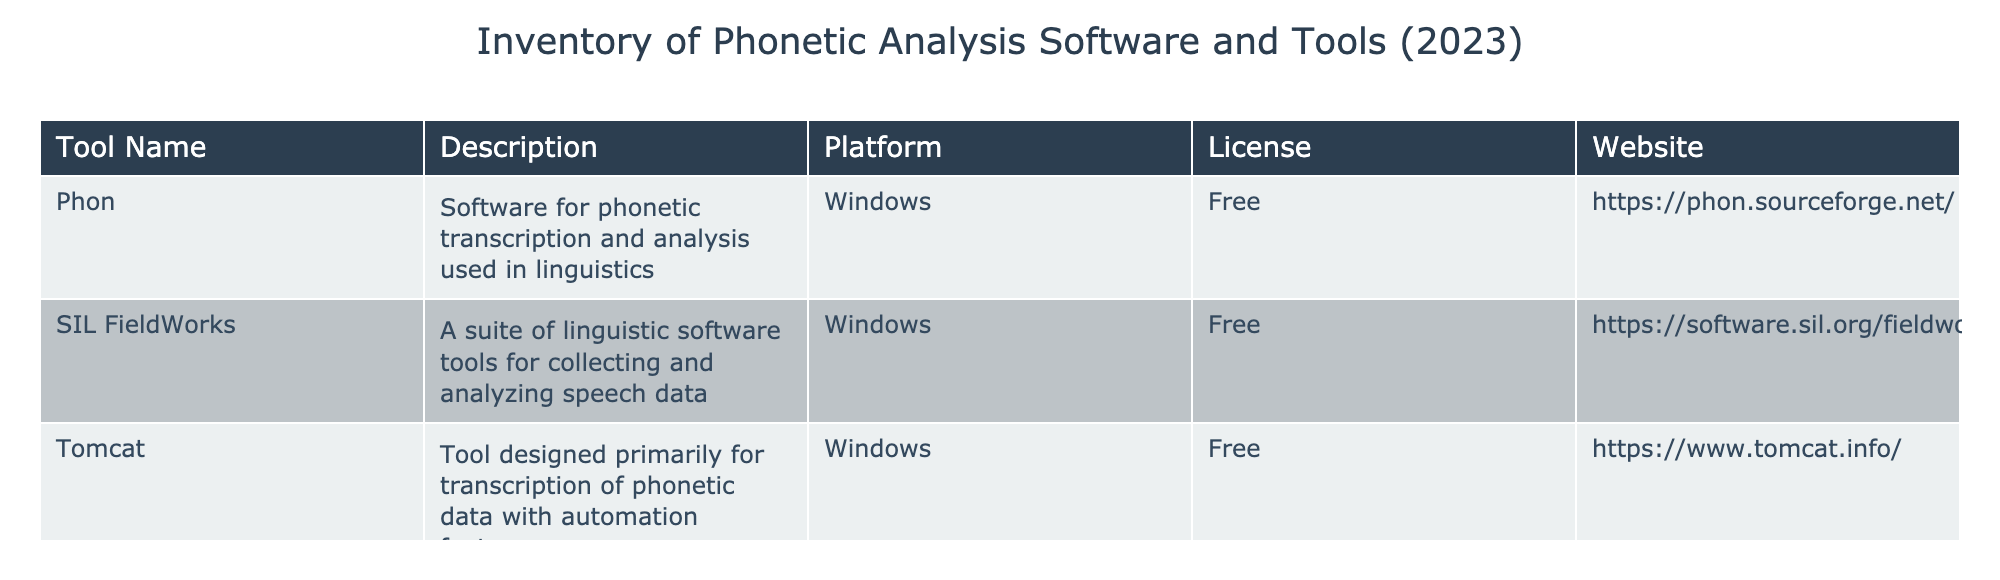What is the name of the software used for phonetic transcription and analysis in linguistics? The table lists "Phon" as the software specifically mentioned for phonetic transcription and analysis in linguistics under the "Description" column.
Answer: Phon Which tools are offered for the Windows platform? All tools listed in the table ("Phon", "SIL FieldWorks", and "Tomcat") are specified to be available on the Windows platform, as indicated in the "Platform" column.
Answer: Phon, SIL FieldWorks, Tomcat Is there any tool in the inventory that requires a paid license? By reviewing the "License" column in the table, all tools listed are marked as "Free", indicating no tool requires a paid license.
Answer: No How many tools in the inventory are available for free? The table contains three tools, all of which are labeled under the "License" column as "Free". Therefore, the total count of tools available for free is 3.
Answer: 3 What website can be visited to access the "SIL FieldWorks" tool? The table provides the website link for "SIL FieldWorks" as listed under the "Website" column. The corresponding link is "https://software.sil.org/fieldworks/".
Answer: https://software.sil.org/fieldworks/ Which tool has a description focusing on transcription and also includes automation features? "Tomcat" is noted in the table as a tool designed primarily for transcription of phonetic data with specific mention of automation features in the "Description" column.
Answer: Tomcat Which tool listed is specifically designated for collecting and analyzing speech data? The description of "SIL FieldWorks" clearly states that it is a suite of linguistic software tools for collecting and analyzing speech data, confirming its specific designation for this purpose.
Answer: SIL FieldWorks Is "Phon" the only tool mentioned that offers analysis features? The table lists "Phon" for phonetic transcription and analysis, but also "SIL FieldWorks" is represented as a software suite for collecting and analyzing speech data, indicating that Phon is not the only tool with analysis features.
Answer: No Which tools could be suitable for a linguist working exclusively on Windows with free software? Based on the "Platform" and "License" columns, all three tools, "Phon", "SIL FieldWorks", and "Tomcat", suit a linguist working on Windows as they are all free.
Answer: Phon, SIL FieldWorks, Tomcat 